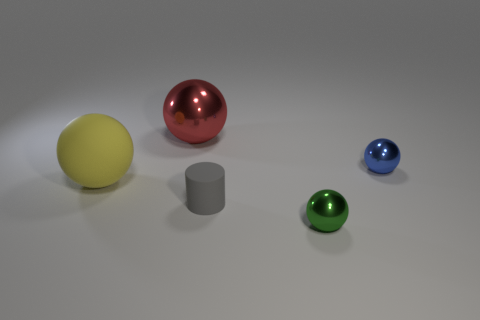Are there any small shiny balls in front of the large yellow rubber ball behind the object that is in front of the small matte cylinder? yes 